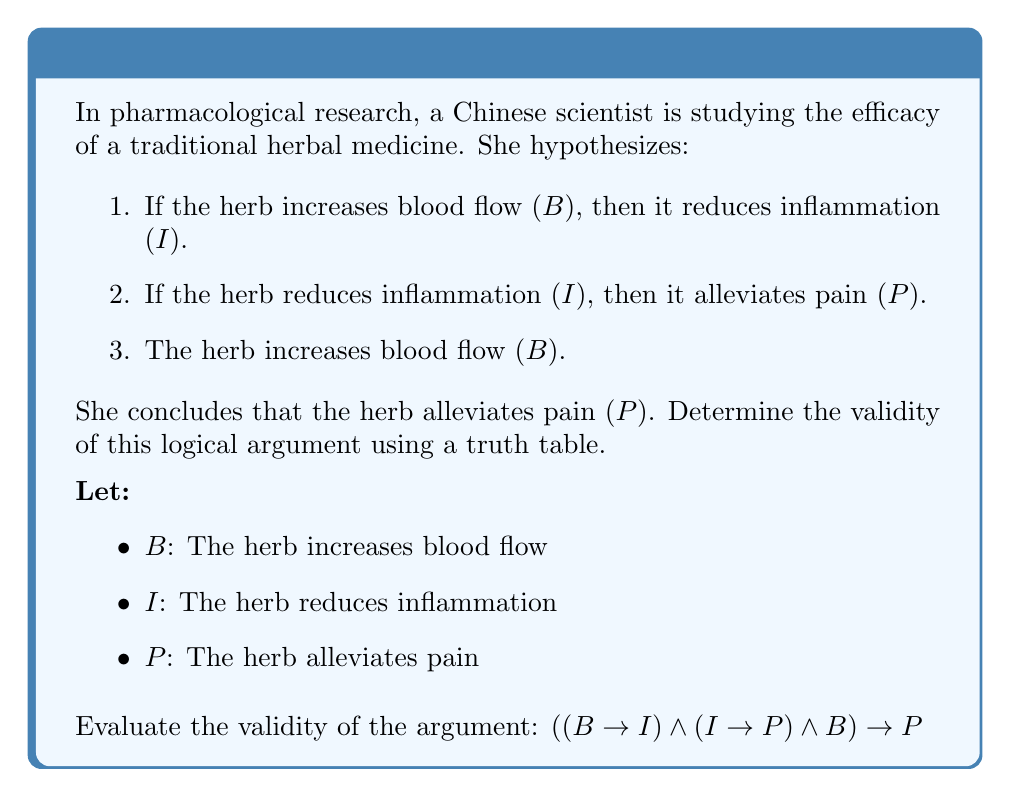Could you help me with this problem? To determine the validity of this logical argument, we need to construct a truth table for the given proposition:

$((B \rightarrow I) \land (I \rightarrow P) \land B) \rightarrow P$

Step 1: Identify the atomic propositions: B, I, and P.

Step 2: List all possible combinations of truth values for B, I, and P.

Step 3: Evaluate each component of the argument:
- $B \rightarrow I$
- $I \rightarrow P$
- $B$
- The conjunction of these three: $(B \rightarrow I) \land (I \rightarrow P) \land B$

Step 4: Evaluate the entire proposition.

Truth Table:

| B | I | P | $B \rightarrow I$ | $I \rightarrow P$ | $(B \rightarrow I) \land (I \rightarrow P) \land B$ | $((B \rightarrow I) \land (I \rightarrow P) \land B) \rightarrow P$ |
|---|---|---|------------------|------------------|--------------------------------------------------|-----------------------------------------------------------|
| T | T | T | T                | T                | T                                                | T                                                         |
| T | T | F | T                | F                | F                                                | T                                                         |
| T | F | T | F                | T                | F                                                | T                                                         |
| T | F | F | F                | T                | F                                                | T                                                         |
| F | T | T | T                | T                | F                                                | T                                                         |
| F | T | F | T                | F                | F                                                | T                                                         |
| F | F | T | T                | T                | F                                                | T                                                         |
| F | F | F | T                | T                | F                                                | T                                                         |

Step 5: Analyze the result.
For an argument to be valid, the conclusion must be true whenever all premises are true. In this case, we need to look at the rows where $(B \rightarrow I) \land (I \rightarrow P) \land B$ is true (which represents all premises being true).

We can see that there is only one row where all premises are true (the first row), and in this row, the conclusion P is also true.

Therefore, the argument is valid. Whenever all premises are true, the conclusion is necessarily true.
Answer: Valid 